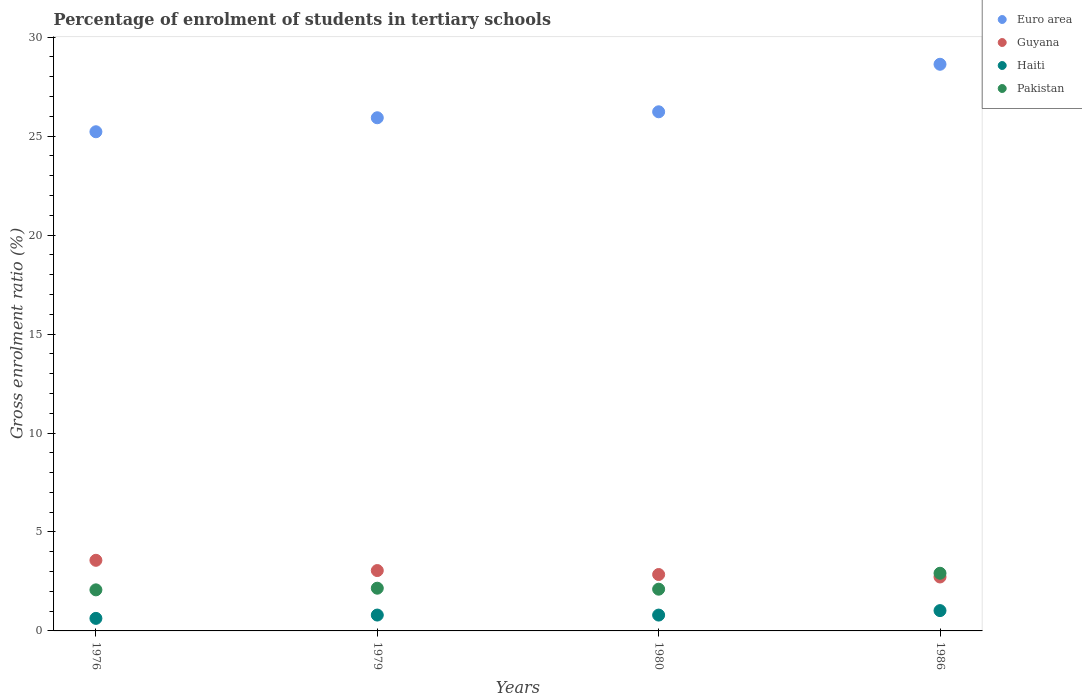How many different coloured dotlines are there?
Offer a terse response. 4. What is the percentage of students enrolled in tertiary schools in Guyana in 1980?
Offer a terse response. 2.85. Across all years, what is the maximum percentage of students enrolled in tertiary schools in Pakistan?
Offer a very short reply. 2.91. Across all years, what is the minimum percentage of students enrolled in tertiary schools in Guyana?
Provide a succinct answer. 2.73. In which year was the percentage of students enrolled in tertiary schools in Haiti maximum?
Give a very brief answer. 1986. In which year was the percentage of students enrolled in tertiary schools in Haiti minimum?
Ensure brevity in your answer.  1976. What is the total percentage of students enrolled in tertiary schools in Haiti in the graph?
Your answer should be compact. 3.26. What is the difference between the percentage of students enrolled in tertiary schools in Pakistan in 1976 and that in 1980?
Your response must be concise. -0.03. What is the difference between the percentage of students enrolled in tertiary schools in Euro area in 1979 and the percentage of students enrolled in tertiary schools in Guyana in 1976?
Offer a very short reply. 22.36. What is the average percentage of students enrolled in tertiary schools in Haiti per year?
Provide a succinct answer. 0.82. In the year 1986, what is the difference between the percentage of students enrolled in tertiary schools in Euro area and percentage of students enrolled in tertiary schools in Pakistan?
Your answer should be very brief. 25.72. In how many years, is the percentage of students enrolled in tertiary schools in Euro area greater than 2 %?
Your response must be concise. 4. What is the ratio of the percentage of students enrolled in tertiary schools in Euro area in 1976 to that in 1986?
Your answer should be very brief. 0.88. Is the percentage of students enrolled in tertiary schools in Guyana in 1979 less than that in 1980?
Keep it short and to the point. No. What is the difference between the highest and the second highest percentage of students enrolled in tertiary schools in Pakistan?
Make the answer very short. 0.76. What is the difference between the highest and the lowest percentage of students enrolled in tertiary schools in Guyana?
Provide a succinct answer. 0.84. In how many years, is the percentage of students enrolled in tertiary schools in Haiti greater than the average percentage of students enrolled in tertiary schools in Haiti taken over all years?
Give a very brief answer. 1. Is the sum of the percentage of students enrolled in tertiary schools in Pakistan in 1979 and 1986 greater than the maximum percentage of students enrolled in tertiary schools in Euro area across all years?
Your answer should be compact. No. Is it the case that in every year, the sum of the percentage of students enrolled in tertiary schools in Guyana and percentage of students enrolled in tertiary schools in Pakistan  is greater than the sum of percentage of students enrolled in tertiary schools in Euro area and percentage of students enrolled in tertiary schools in Haiti?
Keep it short and to the point. Yes. Is the percentage of students enrolled in tertiary schools in Euro area strictly less than the percentage of students enrolled in tertiary schools in Pakistan over the years?
Offer a terse response. No. Where does the legend appear in the graph?
Provide a succinct answer. Top right. What is the title of the graph?
Give a very brief answer. Percentage of enrolment of students in tertiary schools. Does "Ethiopia" appear as one of the legend labels in the graph?
Your answer should be very brief. No. What is the label or title of the X-axis?
Offer a terse response. Years. What is the label or title of the Y-axis?
Your response must be concise. Gross enrolment ratio (%). What is the Gross enrolment ratio (%) of Euro area in 1976?
Your answer should be compact. 25.22. What is the Gross enrolment ratio (%) in Guyana in 1976?
Your answer should be compact. 3.57. What is the Gross enrolment ratio (%) in Haiti in 1976?
Make the answer very short. 0.63. What is the Gross enrolment ratio (%) in Pakistan in 1976?
Offer a terse response. 2.08. What is the Gross enrolment ratio (%) in Euro area in 1979?
Your answer should be compact. 25.93. What is the Gross enrolment ratio (%) in Guyana in 1979?
Your answer should be compact. 3.05. What is the Gross enrolment ratio (%) in Haiti in 1979?
Your answer should be compact. 0.8. What is the Gross enrolment ratio (%) of Pakistan in 1979?
Your answer should be very brief. 2.16. What is the Gross enrolment ratio (%) in Euro area in 1980?
Offer a very short reply. 26.23. What is the Gross enrolment ratio (%) in Guyana in 1980?
Give a very brief answer. 2.85. What is the Gross enrolment ratio (%) in Haiti in 1980?
Provide a succinct answer. 0.8. What is the Gross enrolment ratio (%) of Pakistan in 1980?
Ensure brevity in your answer.  2.11. What is the Gross enrolment ratio (%) in Euro area in 1986?
Offer a very short reply. 28.63. What is the Gross enrolment ratio (%) of Guyana in 1986?
Provide a succinct answer. 2.73. What is the Gross enrolment ratio (%) of Haiti in 1986?
Give a very brief answer. 1.03. What is the Gross enrolment ratio (%) in Pakistan in 1986?
Your response must be concise. 2.91. Across all years, what is the maximum Gross enrolment ratio (%) of Euro area?
Offer a terse response. 28.63. Across all years, what is the maximum Gross enrolment ratio (%) of Guyana?
Provide a short and direct response. 3.57. Across all years, what is the maximum Gross enrolment ratio (%) of Haiti?
Give a very brief answer. 1.03. Across all years, what is the maximum Gross enrolment ratio (%) in Pakistan?
Provide a short and direct response. 2.91. Across all years, what is the minimum Gross enrolment ratio (%) of Euro area?
Give a very brief answer. 25.22. Across all years, what is the minimum Gross enrolment ratio (%) in Guyana?
Ensure brevity in your answer.  2.73. Across all years, what is the minimum Gross enrolment ratio (%) of Haiti?
Offer a very short reply. 0.63. Across all years, what is the minimum Gross enrolment ratio (%) of Pakistan?
Offer a very short reply. 2.08. What is the total Gross enrolment ratio (%) of Euro area in the graph?
Offer a very short reply. 106.02. What is the total Gross enrolment ratio (%) of Guyana in the graph?
Give a very brief answer. 12.19. What is the total Gross enrolment ratio (%) in Haiti in the graph?
Ensure brevity in your answer.  3.26. What is the total Gross enrolment ratio (%) in Pakistan in the graph?
Ensure brevity in your answer.  9.26. What is the difference between the Gross enrolment ratio (%) in Euro area in 1976 and that in 1979?
Give a very brief answer. -0.71. What is the difference between the Gross enrolment ratio (%) of Guyana in 1976 and that in 1979?
Provide a short and direct response. 0.52. What is the difference between the Gross enrolment ratio (%) in Haiti in 1976 and that in 1979?
Give a very brief answer. -0.17. What is the difference between the Gross enrolment ratio (%) of Pakistan in 1976 and that in 1979?
Make the answer very short. -0.08. What is the difference between the Gross enrolment ratio (%) of Euro area in 1976 and that in 1980?
Make the answer very short. -1.01. What is the difference between the Gross enrolment ratio (%) of Guyana in 1976 and that in 1980?
Your answer should be very brief. 0.72. What is the difference between the Gross enrolment ratio (%) in Haiti in 1976 and that in 1980?
Provide a succinct answer. -0.17. What is the difference between the Gross enrolment ratio (%) in Pakistan in 1976 and that in 1980?
Offer a very short reply. -0.03. What is the difference between the Gross enrolment ratio (%) in Euro area in 1976 and that in 1986?
Provide a succinct answer. -3.41. What is the difference between the Gross enrolment ratio (%) in Guyana in 1976 and that in 1986?
Your answer should be compact. 0.84. What is the difference between the Gross enrolment ratio (%) in Haiti in 1976 and that in 1986?
Your answer should be compact. -0.39. What is the difference between the Gross enrolment ratio (%) of Pakistan in 1976 and that in 1986?
Offer a very short reply. -0.84. What is the difference between the Gross enrolment ratio (%) of Euro area in 1979 and that in 1980?
Offer a terse response. -0.3. What is the difference between the Gross enrolment ratio (%) in Guyana in 1979 and that in 1980?
Keep it short and to the point. 0.2. What is the difference between the Gross enrolment ratio (%) in Haiti in 1979 and that in 1980?
Ensure brevity in your answer.  0. What is the difference between the Gross enrolment ratio (%) of Pakistan in 1979 and that in 1980?
Your response must be concise. 0.05. What is the difference between the Gross enrolment ratio (%) of Euro area in 1979 and that in 1986?
Provide a short and direct response. -2.7. What is the difference between the Gross enrolment ratio (%) in Guyana in 1979 and that in 1986?
Keep it short and to the point. 0.32. What is the difference between the Gross enrolment ratio (%) of Haiti in 1979 and that in 1986?
Give a very brief answer. -0.22. What is the difference between the Gross enrolment ratio (%) of Pakistan in 1979 and that in 1986?
Keep it short and to the point. -0.76. What is the difference between the Gross enrolment ratio (%) of Euro area in 1980 and that in 1986?
Ensure brevity in your answer.  -2.4. What is the difference between the Gross enrolment ratio (%) of Guyana in 1980 and that in 1986?
Ensure brevity in your answer.  0.12. What is the difference between the Gross enrolment ratio (%) of Haiti in 1980 and that in 1986?
Make the answer very short. -0.23. What is the difference between the Gross enrolment ratio (%) in Pakistan in 1980 and that in 1986?
Ensure brevity in your answer.  -0.8. What is the difference between the Gross enrolment ratio (%) of Euro area in 1976 and the Gross enrolment ratio (%) of Guyana in 1979?
Your response must be concise. 22.17. What is the difference between the Gross enrolment ratio (%) in Euro area in 1976 and the Gross enrolment ratio (%) in Haiti in 1979?
Provide a short and direct response. 24.42. What is the difference between the Gross enrolment ratio (%) in Euro area in 1976 and the Gross enrolment ratio (%) in Pakistan in 1979?
Your answer should be compact. 23.06. What is the difference between the Gross enrolment ratio (%) in Guyana in 1976 and the Gross enrolment ratio (%) in Haiti in 1979?
Provide a short and direct response. 2.77. What is the difference between the Gross enrolment ratio (%) of Guyana in 1976 and the Gross enrolment ratio (%) of Pakistan in 1979?
Make the answer very short. 1.41. What is the difference between the Gross enrolment ratio (%) in Haiti in 1976 and the Gross enrolment ratio (%) in Pakistan in 1979?
Your answer should be very brief. -1.52. What is the difference between the Gross enrolment ratio (%) in Euro area in 1976 and the Gross enrolment ratio (%) in Guyana in 1980?
Your answer should be very brief. 22.37. What is the difference between the Gross enrolment ratio (%) of Euro area in 1976 and the Gross enrolment ratio (%) of Haiti in 1980?
Ensure brevity in your answer.  24.42. What is the difference between the Gross enrolment ratio (%) in Euro area in 1976 and the Gross enrolment ratio (%) in Pakistan in 1980?
Your answer should be very brief. 23.11. What is the difference between the Gross enrolment ratio (%) in Guyana in 1976 and the Gross enrolment ratio (%) in Haiti in 1980?
Offer a very short reply. 2.77. What is the difference between the Gross enrolment ratio (%) of Guyana in 1976 and the Gross enrolment ratio (%) of Pakistan in 1980?
Make the answer very short. 1.46. What is the difference between the Gross enrolment ratio (%) in Haiti in 1976 and the Gross enrolment ratio (%) in Pakistan in 1980?
Offer a very short reply. -1.48. What is the difference between the Gross enrolment ratio (%) in Euro area in 1976 and the Gross enrolment ratio (%) in Guyana in 1986?
Offer a terse response. 22.5. What is the difference between the Gross enrolment ratio (%) in Euro area in 1976 and the Gross enrolment ratio (%) in Haiti in 1986?
Provide a succinct answer. 24.2. What is the difference between the Gross enrolment ratio (%) in Euro area in 1976 and the Gross enrolment ratio (%) in Pakistan in 1986?
Your response must be concise. 22.31. What is the difference between the Gross enrolment ratio (%) in Guyana in 1976 and the Gross enrolment ratio (%) in Haiti in 1986?
Keep it short and to the point. 2.54. What is the difference between the Gross enrolment ratio (%) in Guyana in 1976 and the Gross enrolment ratio (%) in Pakistan in 1986?
Your answer should be compact. 0.65. What is the difference between the Gross enrolment ratio (%) in Haiti in 1976 and the Gross enrolment ratio (%) in Pakistan in 1986?
Your answer should be compact. -2.28. What is the difference between the Gross enrolment ratio (%) of Euro area in 1979 and the Gross enrolment ratio (%) of Guyana in 1980?
Ensure brevity in your answer.  23.08. What is the difference between the Gross enrolment ratio (%) in Euro area in 1979 and the Gross enrolment ratio (%) in Haiti in 1980?
Give a very brief answer. 25.13. What is the difference between the Gross enrolment ratio (%) in Euro area in 1979 and the Gross enrolment ratio (%) in Pakistan in 1980?
Provide a succinct answer. 23.82. What is the difference between the Gross enrolment ratio (%) in Guyana in 1979 and the Gross enrolment ratio (%) in Haiti in 1980?
Offer a terse response. 2.25. What is the difference between the Gross enrolment ratio (%) in Guyana in 1979 and the Gross enrolment ratio (%) in Pakistan in 1980?
Offer a very short reply. 0.94. What is the difference between the Gross enrolment ratio (%) in Haiti in 1979 and the Gross enrolment ratio (%) in Pakistan in 1980?
Ensure brevity in your answer.  -1.31. What is the difference between the Gross enrolment ratio (%) of Euro area in 1979 and the Gross enrolment ratio (%) of Guyana in 1986?
Your response must be concise. 23.2. What is the difference between the Gross enrolment ratio (%) in Euro area in 1979 and the Gross enrolment ratio (%) in Haiti in 1986?
Give a very brief answer. 24.9. What is the difference between the Gross enrolment ratio (%) of Euro area in 1979 and the Gross enrolment ratio (%) of Pakistan in 1986?
Ensure brevity in your answer.  23.02. What is the difference between the Gross enrolment ratio (%) of Guyana in 1979 and the Gross enrolment ratio (%) of Haiti in 1986?
Provide a succinct answer. 2.02. What is the difference between the Gross enrolment ratio (%) in Guyana in 1979 and the Gross enrolment ratio (%) in Pakistan in 1986?
Keep it short and to the point. 0.14. What is the difference between the Gross enrolment ratio (%) of Haiti in 1979 and the Gross enrolment ratio (%) of Pakistan in 1986?
Make the answer very short. -2.11. What is the difference between the Gross enrolment ratio (%) in Euro area in 1980 and the Gross enrolment ratio (%) in Guyana in 1986?
Your response must be concise. 23.51. What is the difference between the Gross enrolment ratio (%) of Euro area in 1980 and the Gross enrolment ratio (%) of Haiti in 1986?
Make the answer very short. 25.2. What is the difference between the Gross enrolment ratio (%) of Euro area in 1980 and the Gross enrolment ratio (%) of Pakistan in 1986?
Offer a very short reply. 23.32. What is the difference between the Gross enrolment ratio (%) of Guyana in 1980 and the Gross enrolment ratio (%) of Haiti in 1986?
Provide a short and direct response. 1.82. What is the difference between the Gross enrolment ratio (%) in Guyana in 1980 and the Gross enrolment ratio (%) in Pakistan in 1986?
Your answer should be compact. -0.06. What is the difference between the Gross enrolment ratio (%) of Haiti in 1980 and the Gross enrolment ratio (%) of Pakistan in 1986?
Provide a succinct answer. -2.11. What is the average Gross enrolment ratio (%) in Euro area per year?
Make the answer very short. 26.5. What is the average Gross enrolment ratio (%) of Guyana per year?
Provide a short and direct response. 3.05. What is the average Gross enrolment ratio (%) of Haiti per year?
Keep it short and to the point. 0.82. What is the average Gross enrolment ratio (%) in Pakistan per year?
Keep it short and to the point. 2.31. In the year 1976, what is the difference between the Gross enrolment ratio (%) of Euro area and Gross enrolment ratio (%) of Guyana?
Provide a short and direct response. 21.65. In the year 1976, what is the difference between the Gross enrolment ratio (%) in Euro area and Gross enrolment ratio (%) in Haiti?
Give a very brief answer. 24.59. In the year 1976, what is the difference between the Gross enrolment ratio (%) in Euro area and Gross enrolment ratio (%) in Pakistan?
Offer a very short reply. 23.15. In the year 1976, what is the difference between the Gross enrolment ratio (%) in Guyana and Gross enrolment ratio (%) in Haiti?
Your answer should be compact. 2.93. In the year 1976, what is the difference between the Gross enrolment ratio (%) in Guyana and Gross enrolment ratio (%) in Pakistan?
Make the answer very short. 1.49. In the year 1976, what is the difference between the Gross enrolment ratio (%) of Haiti and Gross enrolment ratio (%) of Pakistan?
Ensure brevity in your answer.  -1.44. In the year 1979, what is the difference between the Gross enrolment ratio (%) of Euro area and Gross enrolment ratio (%) of Guyana?
Provide a short and direct response. 22.88. In the year 1979, what is the difference between the Gross enrolment ratio (%) of Euro area and Gross enrolment ratio (%) of Haiti?
Offer a very short reply. 25.13. In the year 1979, what is the difference between the Gross enrolment ratio (%) in Euro area and Gross enrolment ratio (%) in Pakistan?
Your answer should be very brief. 23.77. In the year 1979, what is the difference between the Gross enrolment ratio (%) in Guyana and Gross enrolment ratio (%) in Haiti?
Make the answer very short. 2.25. In the year 1979, what is the difference between the Gross enrolment ratio (%) of Guyana and Gross enrolment ratio (%) of Pakistan?
Give a very brief answer. 0.89. In the year 1979, what is the difference between the Gross enrolment ratio (%) of Haiti and Gross enrolment ratio (%) of Pakistan?
Keep it short and to the point. -1.36. In the year 1980, what is the difference between the Gross enrolment ratio (%) of Euro area and Gross enrolment ratio (%) of Guyana?
Ensure brevity in your answer.  23.38. In the year 1980, what is the difference between the Gross enrolment ratio (%) in Euro area and Gross enrolment ratio (%) in Haiti?
Your answer should be very brief. 25.43. In the year 1980, what is the difference between the Gross enrolment ratio (%) of Euro area and Gross enrolment ratio (%) of Pakistan?
Ensure brevity in your answer.  24.12. In the year 1980, what is the difference between the Gross enrolment ratio (%) of Guyana and Gross enrolment ratio (%) of Haiti?
Give a very brief answer. 2.05. In the year 1980, what is the difference between the Gross enrolment ratio (%) of Guyana and Gross enrolment ratio (%) of Pakistan?
Your response must be concise. 0.74. In the year 1980, what is the difference between the Gross enrolment ratio (%) in Haiti and Gross enrolment ratio (%) in Pakistan?
Make the answer very short. -1.31. In the year 1986, what is the difference between the Gross enrolment ratio (%) in Euro area and Gross enrolment ratio (%) in Guyana?
Your answer should be compact. 25.91. In the year 1986, what is the difference between the Gross enrolment ratio (%) of Euro area and Gross enrolment ratio (%) of Haiti?
Your answer should be compact. 27.61. In the year 1986, what is the difference between the Gross enrolment ratio (%) in Euro area and Gross enrolment ratio (%) in Pakistan?
Keep it short and to the point. 25.72. In the year 1986, what is the difference between the Gross enrolment ratio (%) of Guyana and Gross enrolment ratio (%) of Haiti?
Your response must be concise. 1.7. In the year 1986, what is the difference between the Gross enrolment ratio (%) in Guyana and Gross enrolment ratio (%) in Pakistan?
Offer a very short reply. -0.19. In the year 1986, what is the difference between the Gross enrolment ratio (%) in Haiti and Gross enrolment ratio (%) in Pakistan?
Your response must be concise. -1.89. What is the ratio of the Gross enrolment ratio (%) in Euro area in 1976 to that in 1979?
Make the answer very short. 0.97. What is the ratio of the Gross enrolment ratio (%) of Guyana in 1976 to that in 1979?
Offer a very short reply. 1.17. What is the ratio of the Gross enrolment ratio (%) of Haiti in 1976 to that in 1979?
Your response must be concise. 0.79. What is the ratio of the Gross enrolment ratio (%) of Pakistan in 1976 to that in 1979?
Offer a terse response. 0.96. What is the ratio of the Gross enrolment ratio (%) of Euro area in 1976 to that in 1980?
Provide a short and direct response. 0.96. What is the ratio of the Gross enrolment ratio (%) in Guyana in 1976 to that in 1980?
Provide a short and direct response. 1.25. What is the ratio of the Gross enrolment ratio (%) in Haiti in 1976 to that in 1980?
Offer a terse response. 0.79. What is the ratio of the Gross enrolment ratio (%) of Pakistan in 1976 to that in 1980?
Provide a succinct answer. 0.98. What is the ratio of the Gross enrolment ratio (%) in Euro area in 1976 to that in 1986?
Provide a short and direct response. 0.88. What is the ratio of the Gross enrolment ratio (%) of Guyana in 1976 to that in 1986?
Make the answer very short. 1.31. What is the ratio of the Gross enrolment ratio (%) of Haiti in 1976 to that in 1986?
Give a very brief answer. 0.62. What is the ratio of the Gross enrolment ratio (%) in Pakistan in 1976 to that in 1986?
Offer a very short reply. 0.71. What is the ratio of the Gross enrolment ratio (%) of Euro area in 1979 to that in 1980?
Ensure brevity in your answer.  0.99. What is the ratio of the Gross enrolment ratio (%) in Guyana in 1979 to that in 1980?
Make the answer very short. 1.07. What is the ratio of the Gross enrolment ratio (%) of Haiti in 1979 to that in 1980?
Keep it short and to the point. 1. What is the ratio of the Gross enrolment ratio (%) in Pakistan in 1979 to that in 1980?
Keep it short and to the point. 1.02. What is the ratio of the Gross enrolment ratio (%) in Euro area in 1979 to that in 1986?
Provide a short and direct response. 0.91. What is the ratio of the Gross enrolment ratio (%) in Guyana in 1979 to that in 1986?
Keep it short and to the point. 1.12. What is the ratio of the Gross enrolment ratio (%) in Haiti in 1979 to that in 1986?
Offer a very short reply. 0.78. What is the ratio of the Gross enrolment ratio (%) in Pakistan in 1979 to that in 1986?
Offer a very short reply. 0.74. What is the ratio of the Gross enrolment ratio (%) in Euro area in 1980 to that in 1986?
Offer a terse response. 0.92. What is the ratio of the Gross enrolment ratio (%) of Guyana in 1980 to that in 1986?
Your answer should be compact. 1.05. What is the ratio of the Gross enrolment ratio (%) of Haiti in 1980 to that in 1986?
Provide a short and direct response. 0.78. What is the ratio of the Gross enrolment ratio (%) in Pakistan in 1980 to that in 1986?
Your answer should be compact. 0.72. What is the difference between the highest and the second highest Gross enrolment ratio (%) in Euro area?
Your answer should be compact. 2.4. What is the difference between the highest and the second highest Gross enrolment ratio (%) in Guyana?
Keep it short and to the point. 0.52. What is the difference between the highest and the second highest Gross enrolment ratio (%) of Haiti?
Ensure brevity in your answer.  0.22. What is the difference between the highest and the second highest Gross enrolment ratio (%) in Pakistan?
Offer a terse response. 0.76. What is the difference between the highest and the lowest Gross enrolment ratio (%) of Euro area?
Give a very brief answer. 3.41. What is the difference between the highest and the lowest Gross enrolment ratio (%) in Guyana?
Make the answer very short. 0.84. What is the difference between the highest and the lowest Gross enrolment ratio (%) in Haiti?
Your answer should be compact. 0.39. What is the difference between the highest and the lowest Gross enrolment ratio (%) in Pakistan?
Give a very brief answer. 0.84. 